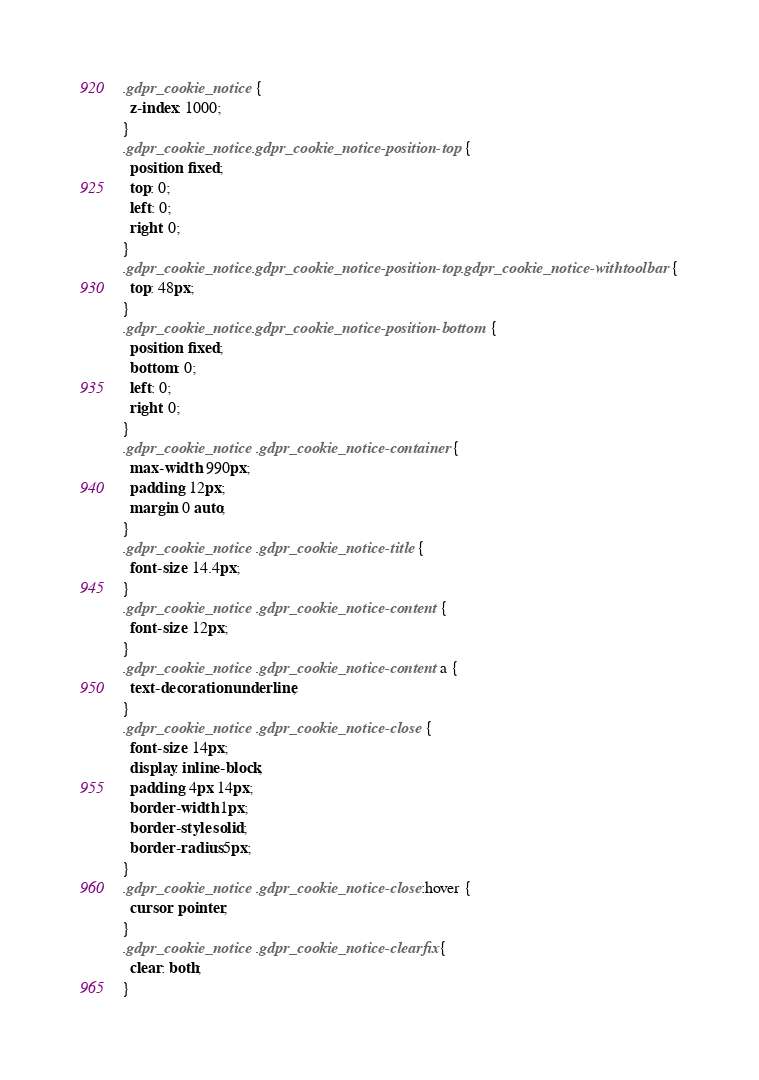<code> <loc_0><loc_0><loc_500><loc_500><_CSS_>.gdpr_cookie_notice {
  z-index: 1000;
}
.gdpr_cookie_notice.gdpr_cookie_notice-position-top {
  position: fixed;
  top: 0;
  left: 0;
  right: 0;
}
.gdpr_cookie_notice.gdpr_cookie_notice-position-top.gdpr_cookie_notice-withtoolbar {
  top: 48px;
}
.gdpr_cookie_notice.gdpr_cookie_notice-position-bottom {
  position: fixed;
  bottom: 0;
  left: 0;
  right: 0;
}
.gdpr_cookie_notice .gdpr_cookie_notice-container {
  max-width: 990px;
  padding: 12px;
  margin: 0 auto;
}
.gdpr_cookie_notice .gdpr_cookie_notice-title {
  font-size: 14.4px;
}
.gdpr_cookie_notice .gdpr_cookie_notice-content {
  font-size: 12px;
}
.gdpr_cookie_notice .gdpr_cookie_notice-content a {
  text-decoration: underline;
}
.gdpr_cookie_notice .gdpr_cookie_notice-close {
  font-size: 14px;
  display: inline-block;
  padding: 4px 14px;
  border-width: 1px;
  border-style: solid;
  border-radius: 5px;
}
.gdpr_cookie_notice .gdpr_cookie_notice-close:hover {
  cursor: pointer;
}
.gdpr_cookie_notice .gdpr_cookie_notice-clearfix {
  clear: both;
}
</code> 